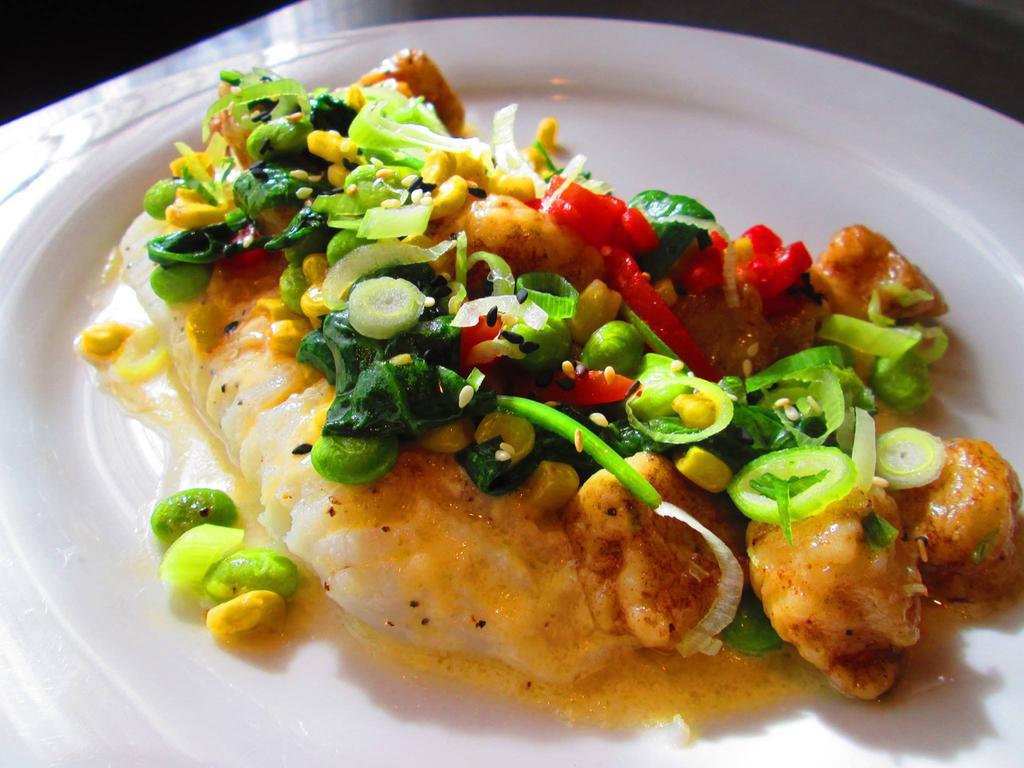Can you describe this image briefly? The picture consists of a dish served in a plate. 